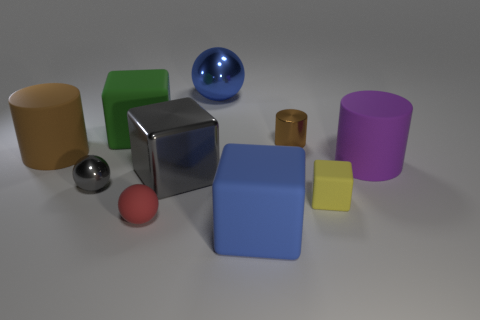Is the shape of the blue object that is in front of the small brown shiny cylinder the same as  the large brown object?
Make the answer very short. No. The yellow matte object has what shape?
Your answer should be very brief. Cube. How many large things have the same material as the gray sphere?
Your response must be concise. 2. There is a small shiny sphere; is its color the same as the small metal thing to the right of the large gray object?
Ensure brevity in your answer.  No. How many small red things are there?
Keep it short and to the point. 1. Is there a small metal cylinder that has the same color as the large shiny block?
Offer a terse response. No. The metal object to the left of the cube that is behind the small metallic object on the right side of the blue rubber object is what color?
Your response must be concise. Gray. Are the big blue cube and the ball behind the gray ball made of the same material?
Your response must be concise. No. What material is the gray ball?
Keep it short and to the point. Metal. What material is the large thing that is the same color as the tiny metallic ball?
Provide a succinct answer. Metal. 